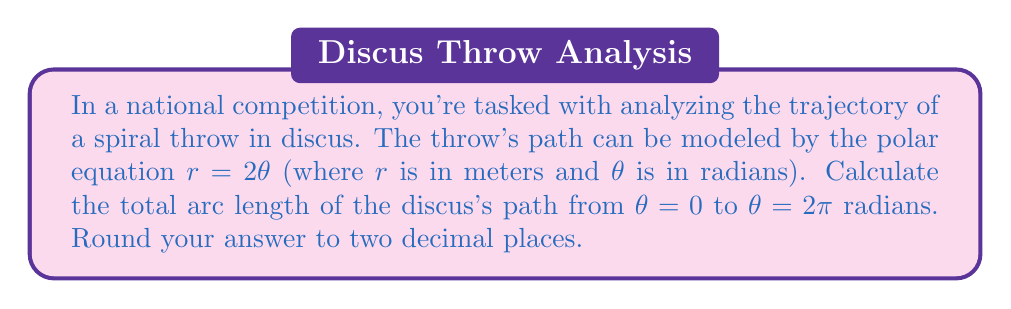Show me your answer to this math problem. To solve this problem, we'll use the formula for arc length in polar coordinates:

$$L = \int_a^b \sqrt{r^2 + \left(\frac{dr}{d\theta}\right)^2} d\theta$$

Where $L$ is the arc length, $r$ is the polar function, and $a$ and $b$ are the starting and ending angles respectively.

Given: $r = 2\theta$

Step 1: Find $\frac{dr}{d\theta}$
$$\frac{dr}{d\theta} = 2$$

Step 2: Substitute into the arc length formula
$$L = \int_0^{2\pi} \sqrt{(2\theta)^2 + 2^2} d\theta$$

Step 3: Simplify under the square root
$$L = \int_0^{2\pi} \sqrt{4\theta^2 + 4} d\theta$$
$$L = 2\int_0^{2\pi} \sqrt{\theta^2 + 1} d\theta$$

Step 4: This integral doesn't have an elementary antiderivative. We can solve it using the substitution $\theta = \sinh u$:

$$L = 2\int_0^{\sinh^{-1}(2\pi)} \sqrt{\sinh^2 u + 1} \cosh u du$$

Step 5: Simplify using the identity $\sinh^2 u + 1 = \cosh^2 u$
$$L = 2\int_0^{\sinh^{-1}(2\pi)} \cosh^2 u du$$

Step 6: Use the identity $\cosh^2 u = \frac{1}{2}(\cosh 2u + 1)$
$$L = \int_0^{\sinh^{-1}(2\pi)} (\cosh 2u + 1) du$$

Step 7: Integrate
$$L = \left[\frac{1}{2}\sinh 2u + u\right]_0^{\sinh^{-1}(2\pi)}$$

Step 8: Evaluate the limits
$$L = \frac{1}{2}\sinh(2\sinh^{-1}(2\pi)) + \sinh^{-1}(2\pi) - 0$$

Step 9: Simplify using $\sinh(2\sinh^{-1}x) = 2x\sqrt{1+x^2}$
$$L = \pi\sqrt{1+(2\pi)^2} + \sinh^{-1}(2\pi)$$

Step 10: Calculate the numerical value and round to two decimal places
$$L \approx 26.45$$
Answer: The arc length of the spiral curve from $\theta = 0$ to $\theta = 2\pi$ radians is approximately 26.45 meters. 